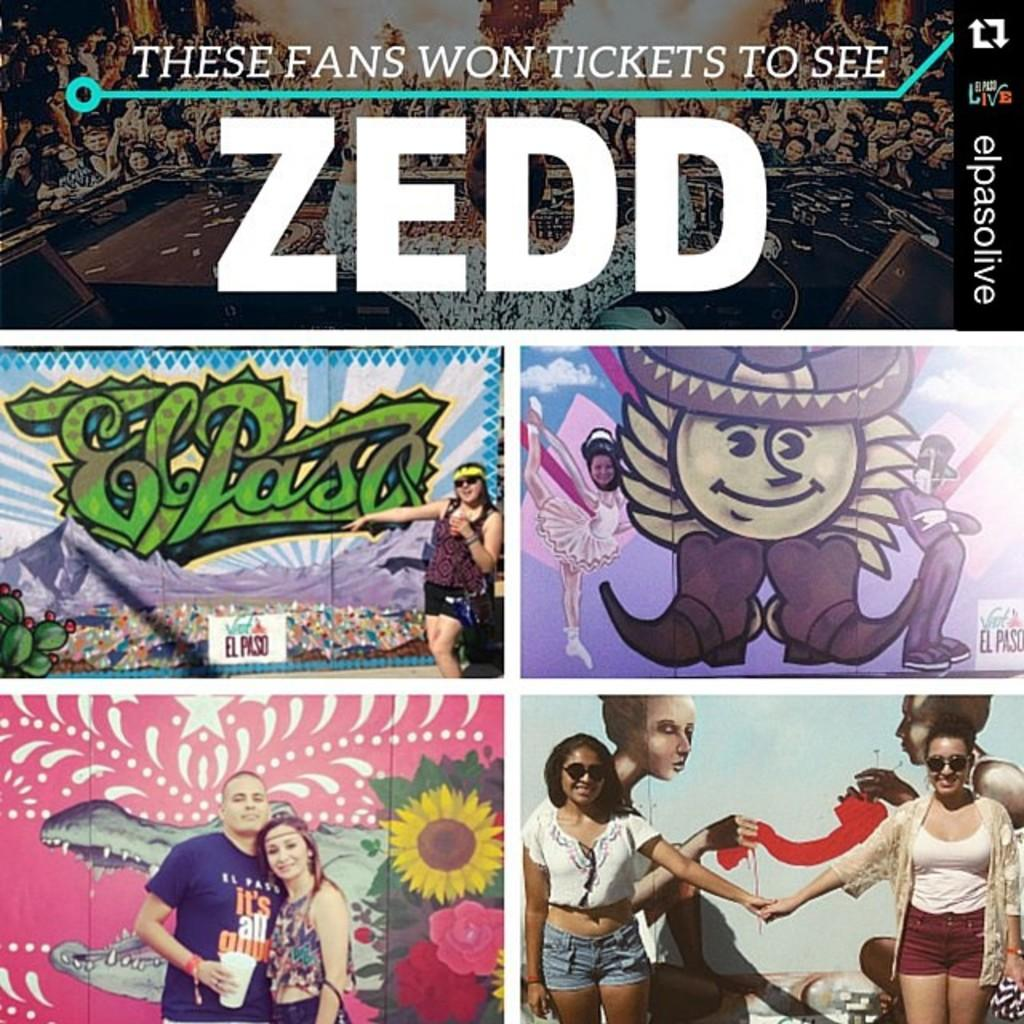Provide a one-sentence caption for the provided image. some music that is for an artist named Zedd. 